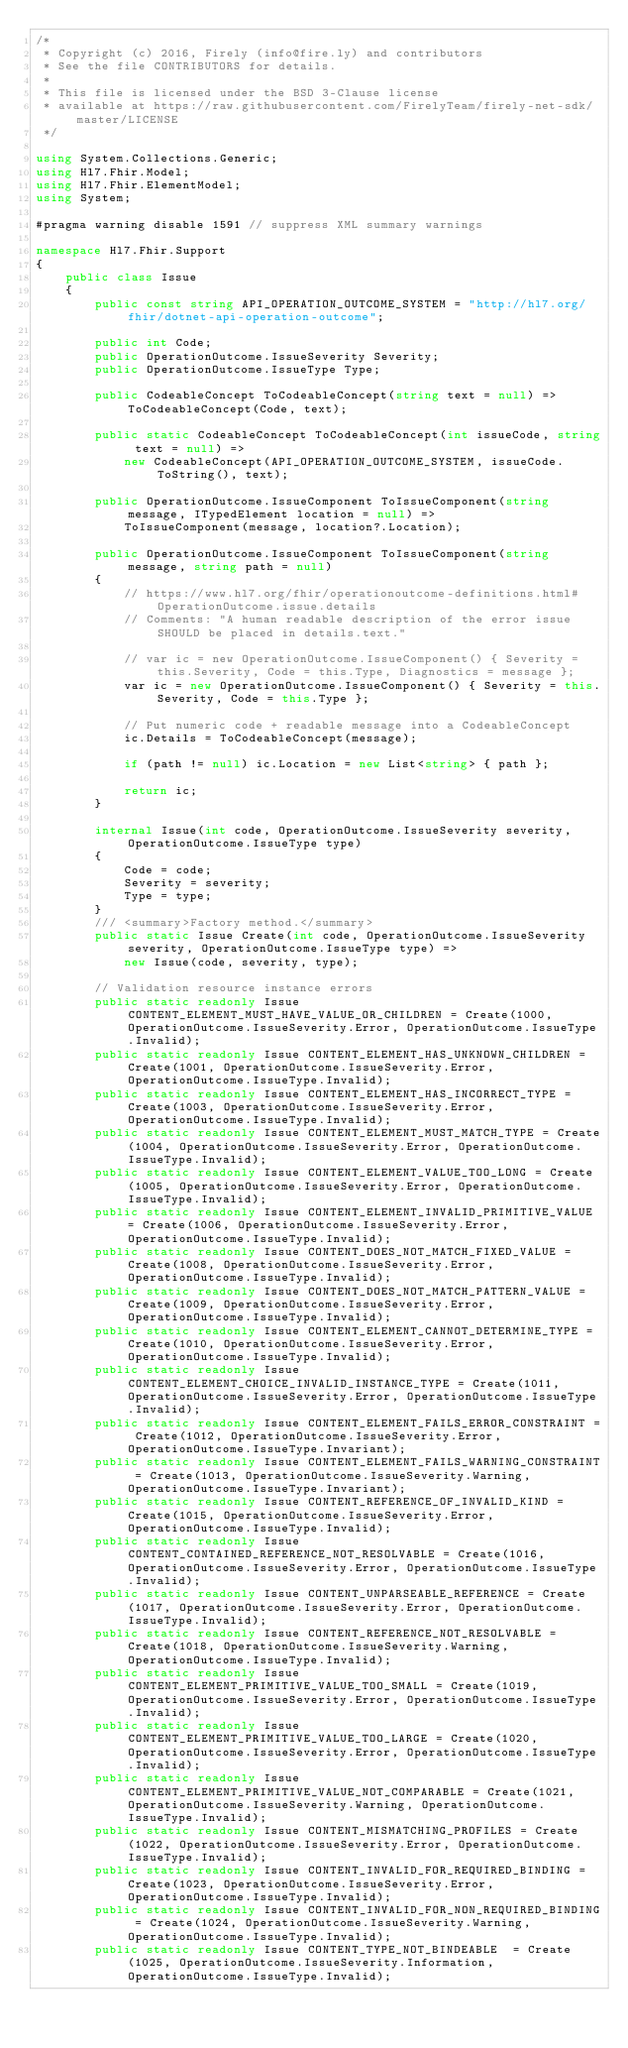Convert code to text. <code><loc_0><loc_0><loc_500><loc_500><_C#_>/* 
 * Copyright (c) 2016, Firely (info@fire.ly) and contributors
 * See the file CONTRIBUTORS for details.
 * 
 * This file is licensed under the BSD 3-Clause license
 * available at https://raw.githubusercontent.com/FirelyTeam/firely-net-sdk/master/LICENSE
 */

using System.Collections.Generic;
using Hl7.Fhir.Model;
using Hl7.Fhir.ElementModel;
using System;

#pragma warning disable 1591 // suppress XML summary warnings

namespace Hl7.Fhir.Support
{
    public class Issue
    {
        public const string API_OPERATION_OUTCOME_SYSTEM = "http://hl7.org/fhir/dotnet-api-operation-outcome";

        public int Code;
        public OperationOutcome.IssueSeverity Severity;
        public OperationOutcome.IssueType Type;

        public CodeableConcept ToCodeableConcept(string text = null) => ToCodeableConcept(Code, text);

        public static CodeableConcept ToCodeableConcept(int issueCode, string text = null) => 
            new CodeableConcept(API_OPERATION_OUTCOME_SYSTEM, issueCode.ToString(), text);

        public OperationOutcome.IssueComponent ToIssueComponent(string message, ITypedElement location = null) => 
            ToIssueComponent(message, location?.Location);

        public OperationOutcome.IssueComponent ToIssueComponent(string message, string path = null)
        {
            // https://www.hl7.org/fhir/operationoutcome-definitions.html#OperationOutcome.issue.details
            // Comments: "A human readable description of the error issue SHOULD be placed in details.text."

            // var ic = new OperationOutcome.IssueComponent() { Severity = this.Severity, Code = this.Type, Diagnostics = message };
            var ic = new OperationOutcome.IssueComponent() { Severity = this.Severity, Code = this.Type };

            // Put numeric code + readable message into a CodeableConcept
            ic.Details = ToCodeableConcept(message);

            if (path != null) ic.Location = new List<string> { path };

            return ic;
        }

        internal Issue(int code, OperationOutcome.IssueSeverity severity, OperationOutcome.IssueType type)
        {
            Code = code;
            Severity = severity;
            Type = type;
        }
        /// <summary>Factory method.</summary>
        public static Issue Create(int code, OperationOutcome.IssueSeverity severity, OperationOutcome.IssueType type) =>
            new Issue(code, severity, type);

        // Validation resource instance errors
        public static readonly Issue CONTENT_ELEMENT_MUST_HAVE_VALUE_OR_CHILDREN = Create(1000, OperationOutcome.IssueSeverity.Error, OperationOutcome.IssueType.Invalid);
        public static readonly Issue CONTENT_ELEMENT_HAS_UNKNOWN_CHILDREN = Create(1001, OperationOutcome.IssueSeverity.Error, OperationOutcome.IssueType.Invalid);
        public static readonly Issue CONTENT_ELEMENT_HAS_INCORRECT_TYPE = Create(1003, OperationOutcome.IssueSeverity.Error, OperationOutcome.IssueType.Invalid);
        public static readonly Issue CONTENT_ELEMENT_MUST_MATCH_TYPE = Create(1004, OperationOutcome.IssueSeverity.Error, OperationOutcome.IssueType.Invalid);
        public static readonly Issue CONTENT_ELEMENT_VALUE_TOO_LONG = Create(1005, OperationOutcome.IssueSeverity.Error, OperationOutcome.IssueType.Invalid);
        public static readonly Issue CONTENT_ELEMENT_INVALID_PRIMITIVE_VALUE = Create(1006, OperationOutcome.IssueSeverity.Error, OperationOutcome.IssueType.Invalid);
        public static readonly Issue CONTENT_DOES_NOT_MATCH_FIXED_VALUE = Create(1008, OperationOutcome.IssueSeverity.Error, OperationOutcome.IssueType.Invalid);
        public static readonly Issue CONTENT_DOES_NOT_MATCH_PATTERN_VALUE = Create(1009, OperationOutcome.IssueSeverity.Error, OperationOutcome.IssueType.Invalid);
        public static readonly Issue CONTENT_ELEMENT_CANNOT_DETERMINE_TYPE = Create(1010, OperationOutcome.IssueSeverity.Error, OperationOutcome.IssueType.Invalid);
        public static readonly Issue CONTENT_ELEMENT_CHOICE_INVALID_INSTANCE_TYPE = Create(1011, OperationOutcome.IssueSeverity.Error, OperationOutcome.IssueType.Invalid);
        public static readonly Issue CONTENT_ELEMENT_FAILS_ERROR_CONSTRAINT = Create(1012, OperationOutcome.IssueSeverity.Error, OperationOutcome.IssueType.Invariant);
        public static readonly Issue CONTENT_ELEMENT_FAILS_WARNING_CONSTRAINT = Create(1013, OperationOutcome.IssueSeverity.Warning, OperationOutcome.IssueType.Invariant);
        public static readonly Issue CONTENT_REFERENCE_OF_INVALID_KIND = Create(1015, OperationOutcome.IssueSeverity.Error, OperationOutcome.IssueType.Invalid);
        public static readonly Issue CONTENT_CONTAINED_REFERENCE_NOT_RESOLVABLE = Create(1016, OperationOutcome.IssueSeverity.Error, OperationOutcome.IssueType.Invalid);
        public static readonly Issue CONTENT_UNPARSEABLE_REFERENCE = Create(1017, OperationOutcome.IssueSeverity.Error, OperationOutcome.IssueType.Invalid);
        public static readonly Issue CONTENT_REFERENCE_NOT_RESOLVABLE = Create(1018, OperationOutcome.IssueSeverity.Warning, OperationOutcome.IssueType.Invalid);
        public static readonly Issue CONTENT_ELEMENT_PRIMITIVE_VALUE_TOO_SMALL = Create(1019, OperationOutcome.IssueSeverity.Error, OperationOutcome.IssueType.Invalid);
        public static readonly Issue CONTENT_ELEMENT_PRIMITIVE_VALUE_TOO_LARGE = Create(1020, OperationOutcome.IssueSeverity.Error, OperationOutcome.IssueType.Invalid);
        public static readonly Issue CONTENT_ELEMENT_PRIMITIVE_VALUE_NOT_COMPARABLE = Create(1021, OperationOutcome.IssueSeverity.Warning, OperationOutcome.IssueType.Invalid);
        public static readonly Issue CONTENT_MISMATCHING_PROFILES = Create(1022, OperationOutcome.IssueSeverity.Error, OperationOutcome.IssueType.Invalid);
        public static readonly Issue CONTENT_INVALID_FOR_REQUIRED_BINDING = Create(1023, OperationOutcome.IssueSeverity.Error, OperationOutcome.IssueType.Invalid);
        public static readonly Issue CONTENT_INVALID_FOR_NON_REQUIRED_BINDING = Create(1024, OperationOutcome.IssueSeverity.Warning, OperationOutcome.IssueType.Invalid);
        public static readonly Issue CONTENT_TYPE_NOT_BINDEABLE  = Create(1025, OperationOutcome.IssueSeverity.Information, OperationOutcome.IssueType.Invalid);</code> 